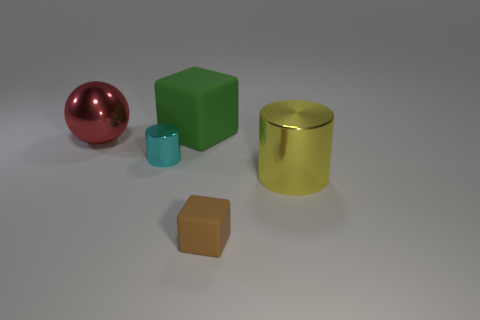Could you describe the lighting in the scene? The lighting in the scene is relatively soft and diffused, coming from above. There are no harsh shadows, indicating either a softly lit room or a set-up with a lightbox or diffuse light sources. This kind of lighting is typical for showcasing objects clearly without creating distracting shadows. 